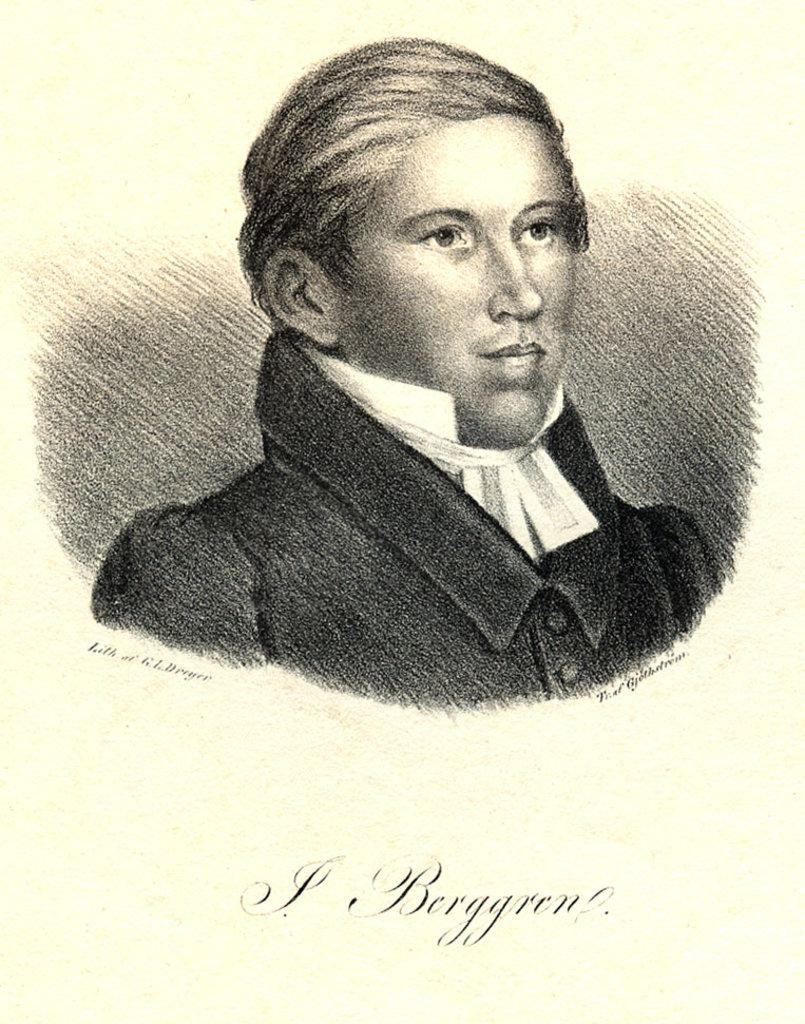What is the main subject of the image? There is a human sketch in the image. What is the color of the surface on which the sketch is drawn? The sketch is on a white surface. Is there any text present in the image? Yes, there is text at the bottom of the image. What type of pancake is being served in the image? There is no pancake present in the image; it features a human sketch on a white surface with text at the bottom. How does the brake function in the image? There is no brake present in the image; it only contains a human sketch, a white surface, and text at the bottom. 